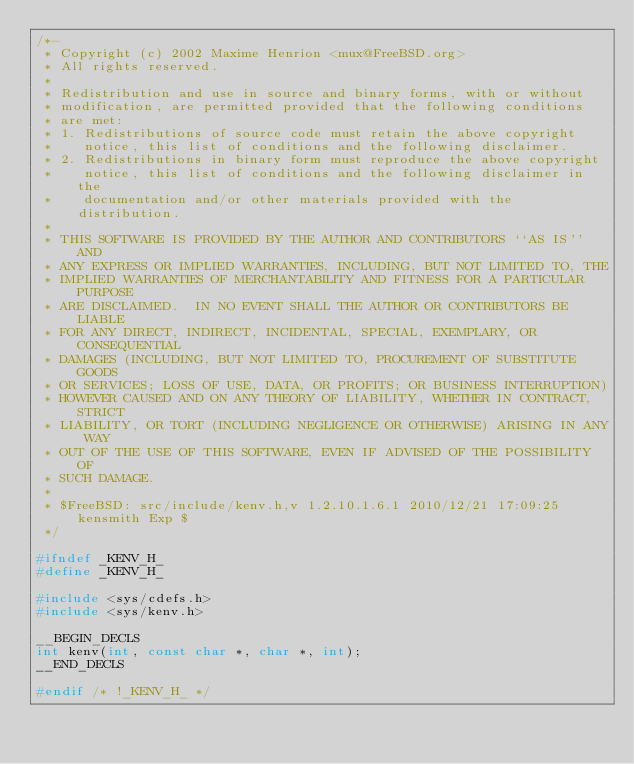Convert code to text. <code><loc_0><loc_0><loc_500><loc_500><_C_>/*-
 * Copyright (c) 2002 Maxime Henrion <mux@FreeBSD.org>
 * All rights reserved.
 *
 * Redistribution and use in source and binary forms, with or without
 * modification, are permitted provided that the following conditions
 * are met:
 * 1. Redistributions of source code must retain the above copyright
 *    notice, this list of conditions and the following disclaimer.
 * 2. Redistributions in binary form must reproduce the above copyright
 *    notice, this list of conditions and the following disclaimer in the
 *    documentation and/or other materials provided with the distribution.
 *
 * THIS SOFTWARE IS PROVIDED BY THE AUTHOR AND CONTRIBUTORS ``AS IS'' AND
 * ANY EXPRESS OR IMPLIED WARRANTIES, INCLUDING, BUT NOT LIMITED TO, THE
 * IMPLIED WARRANTIES OF MERCHANTABILITY AND FITNESS FOR A PARTICULAR PURPOSE
 * ARE DISCLAIMED.  IN NO EVENT SHALL THE AUTHOR OR CONTRIBUTORS BE LIABLE
 * FOR ANY DIRECT, INDIRECT, INCIDENTAL, SPECIAL, EXEMPLARY, OR CONSEQUENTIAL
 * DAMAGES (INCLUDING, BUT NOT LIMITED TO, PROCUREMENT OF SUBSTITUTE GOODS
 * OR SERVICES; LOSS OF USE, DATA, OR PROFITS; OR BUSINESS INTERRUPTION)
 * HOWEVER CAUSED AND ON ANY THEORY OF LIABILITY, WHETHER IN CONTRACT, STRICT
 * LIABILITY, OR TORT (INCLUDING NEGLIGENCE OR OTHERWISE) ARISING IN ANY WAY
 * OUT OF THE USE OF THIS SOFTWARE, EVEN IF ADVISED OF THE POSSIBILITY OF
 * SUCH DAMAGE.
 *
 * $FreeBSD: src/include/kenv.h,v 1.2.10.1.6.1 2010/12/21 17:09:25 kensmith Exp $
 */

#ifndef _KENV_H_
#define _KENV_H_

#include <sys/cdefs.h>
#include <sys/kenv.h>

__BEGIN_DECLS
int kenv(int, const char *, char *, int);
__END_DECLS

#endif /* !_KENV_H_ */
</code> 